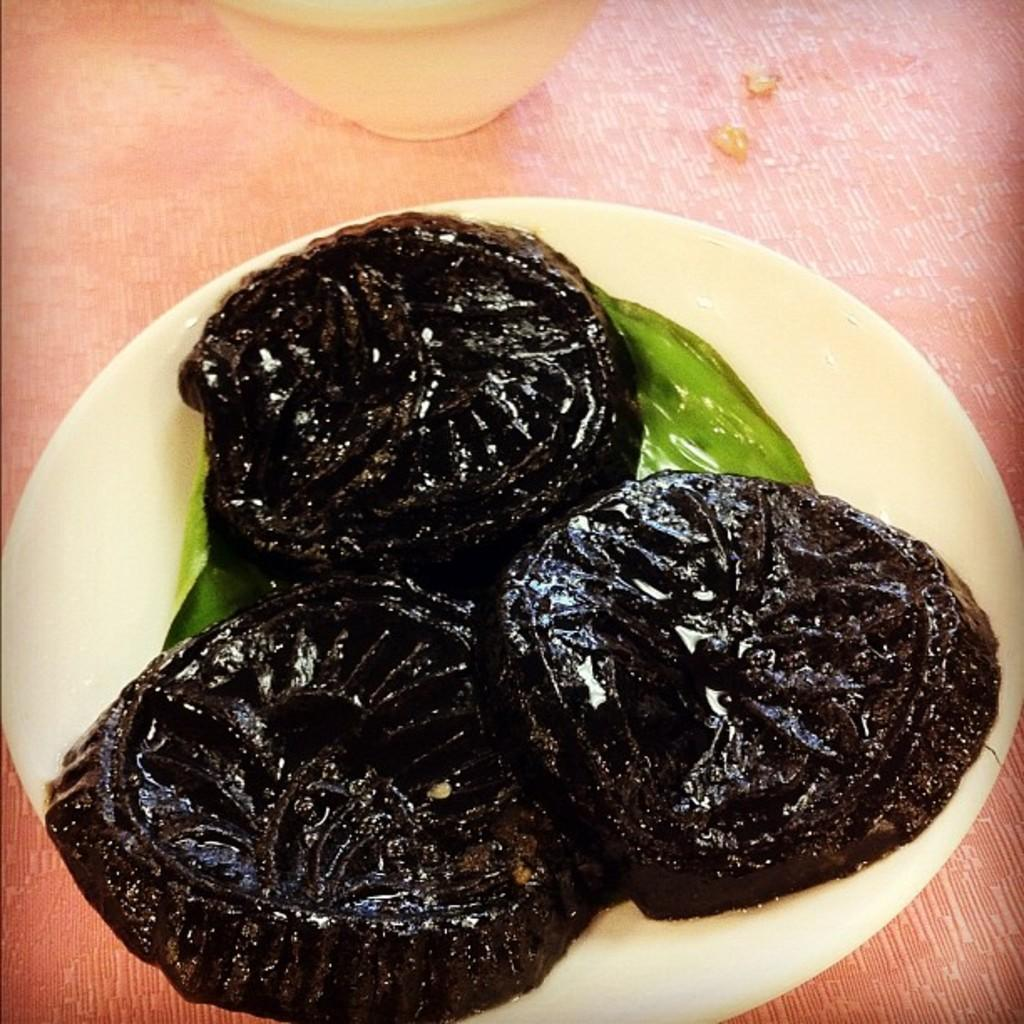What is present on the plate in the image? There is food in a plate in the image. Can you describe the object at the top of the image? There is a bowl at the top of the image. How many men are cooking on the stove in the image? There is no stove or men present in the image. What type of glove can be seen in the image? There is no glove present in the image. 